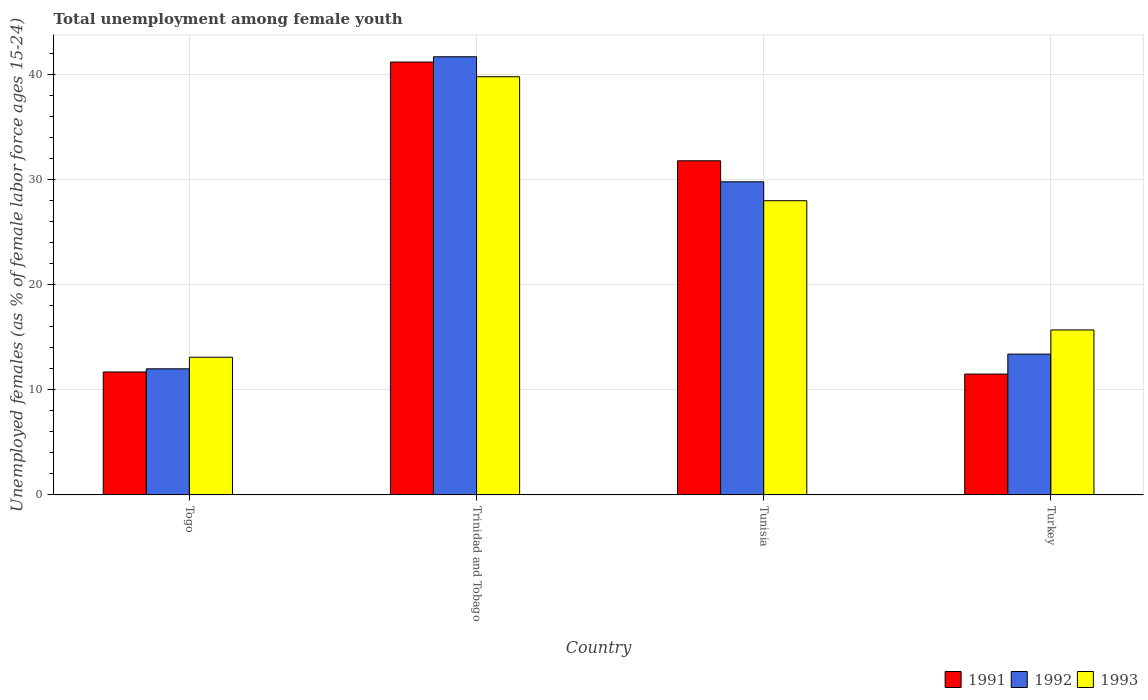How many different coloured bars are there?
Provide a succinct answer. 3. Are the number of bars per tick equal to the number of legend labels?
Offer a terse response. Yes. How many bars are there on the 2nd tick from the left?
Your answer should be compact. 3. What is the label of the 2nd group of bars from the left?
Your response must be concise. Trinidad and Tobago. What is the percentage of unemployed females in in 1992 in Trinidad and Tobago?
Offer a very short reply. 41.7. Across all countries, what is the maximum percentage of unemployed females in in 1992?
Ensure brevity in your answer.  41.7. Across all countries, what is the minimum percentage of unemployed females in in 1993?
Your answer should be very brief. 13.1. In which country was the percentage of unemployed females in in 1992 maximum?
Provide a succinct answer. Trinidad and Tobago. In which country was the percentage of unemployed females in in 1992 minimum?
Your answer should be very brief. Togo. What is the total percentage of unemployed females in in 1993 in the graph?
Your answer should be compact. 96.6. What is the difference between the percentage of unemployed females in in 1993 in Togo and that in Trinidad and Tobago?
Your response must be concise. -26.7. What is the difference between the percentage of unemployed females in in 1991 in Tunisia and the percentage of unemployed females in in 1992 in Trinidad and Tobago?
Provide a short and direct response. -9.9. What is the average percentage of unemployed females in in 1992 per country?
Your answer should be very brief. 24.22. What is the ratio of the percentage of unemployed females in in 1992 in Tunisia to that in Turkey?
Provide a short and direct response. 2.22. Is the percentage of unemployed females in in 1992 in Tunisia less than that in Turkey?
Offer a very short reply. No. Is the difference between the percentage of unemployed females in in 1991 in Trinidad and Tobago and Turkey greater than the difference between the percentage of unemployed females in in 1992 in Trinidad and Tobago and Turkey?
Your answer should be compact. Yes. What is the difference between the highest and the second highest percentage of unemployed females in in 1991?
Offer a very short reply. 29.5. What is the difference between the highest and the lowest percentage of unemployed females in in 1992?
Ensure brevity in your answer.  29.7. In how many countries, is the percentage of unemployed females in in 1991 greater than the average percentage of unemployed females in in 1991 taken over all countries?
Make the answer very short. 2. What does the 3rd bar from the right in Tunisia represents?
Provide a succinct answer. 1991. Is it the case that in every country, the sum of the percentage of unemployed females in in 1993 and percentage of unemployed females in in 1992 is greater than the percentage of unemployed females in in 1991?
Ensure brevity in your answer.  Yes. How many bars are there?
Your answer should be very brief. 12. Are all the bars in the graph horizontal?
Make the answer very short. No. How many countries are there in the graph?
Offer a very short reply. 4. What is the difference between two consecutive major ticks on the Y-axis?
Provide a succinct answer. 10. Are the values on the major ticks of Y-axis written in scientific E-notation?
Provide a short and direct response. No. Does the graph contain grids?
Your answer should be very brief. Yes. Where does the legend appear in the graph?
Keep it short and to the point. Bottom right. What is the title of the graph?
Your response must be concise. Total unemployment among female youth. Does "1991" appear as one of the legend labels in the graph?
Offer a terse response. Yes. What is the label or title of the X-axis?
Your answer should be compact. Country. What is the label or title of the Y-axis?
Ensure brevity in your answer.  Unemployed females (as % of female labor force ages 15-24). What is the Unemployed females (as % of female labor force ages 15-24) of 1991 in Togo?
Make the answer very short. 11.7. What is the Unemployed females (as % of female labor force ages 15-24) in 1993 in Togo?
Your answer should be compact. 13.1. What is the Unemployed females (as % of female labor force ages 15-24) in 1991 in Trinidad and Tobago?
Provide a short and direct response. 41.2. What is the Unemployed females (as % of female labor force ages 15-24) of 1992 in Trinidad and Tobago?
Your answer should be very brief. 41.7. What is the Unemployed females (as % of female labor force ages 15-24) of 1993 in Trinidad and Tobago?
Give a very brief answer. 39.8. What is the Unemployed females (as % of female labor force ages 15-24) in 1991 in Tunisia?
Provide a succinct answer. 31.8. What is the Unemployed females (as % of female labor force ages 15-24) in 1992 in Tunisia?
Ensure brevity in your answer.  29.8. What is the Unemployed females (as % of female labor force ages 15-24) in 1992 in Turkey?
Offer a terse response. 13.4. What is the Unemployed females (as % of female labor force ages 15-24) in 1993 in Turkey?
Provide a short and direct response. 15.7. Across all countries, what is the maximum Unemployed females (as % of female labor force ages 15-24) in 1991?
Your answer should be compact. 41.2. Across all countries, what is the maximum Unemployed females (as % of female labor force ages 15-24) in 1992?
Make the answer very short. 41.7. Across all countries, what is the maximum Unemployed females (as % of female labor force ages 15-24) in 1993?
Your answer should be very brief. 39.8. Across all countries, what is the minimum Unemployed females (as % of female labor force ages 15-24) in 1992?
Offer a very short reply. 12. Across all countries, what is the minimum Unemployed females (as % of female labor force ages 15-24) of 1993?
Provide a short and direct response. 13.1. What is the total Unemployed females (as % of female labor force ages 15-24) in 1991 in the graph?
Give a very brief answer. 96.2. What is the total Unemployed females (as % of female labor force ages 15-24) in 1992 in the graph?
Offer a very short reply. 96.9. What is the total Unemployed females (as % of female labor force ages 15-24) of 1993 in the graph?
Offer a terse response. 96.6. What is the difference between the Unemployed females (as % of female labor force ages 15-24) in 1991 in Togo and that in Trinidad and Tobago?
Ensure brevity in your answer.  -29.5. What is the difference between the Unemployed females (as % of female labor force ages 15-24) in 1992 in Togo and that in Trinidad and Tobago?
Your answer should be compact. -29.7. What is the difference between the Unemployed females (as % of female labor force ages 15-24) in 1993 in Togo and that in Trinidad and Tobago?
Offer a terse response. -26.7. What is the difference between the Unemployed females (as % of female labor force ages 15-24) in 1991 in Togo and that in Tunisia?
Keep it short and to the point. -20.1. What is the difference between the Unemployed females (as % of female labor force ages 15-24) in 1992 in Togo and that in Tunisia?
Keep it short and to the point. -17.8. What is the difference between the Unemployed females (as % of female labor force ages 15-24) of 1993 in Togo and that in Tunisia?
Provide a succinct answer. -14.9. What is the difference between the Unemployed females (as % of female labor force ages 15-24) of 1992 in Togo and that in Turkey?
Offer a terse response. -1.4. What is the difference between the Unemployed females (as % of female labor force ages 15-24) of 1993 in Trinidad and Tobago and that in Tunisia?
Offer a very short reply. 11.8. What is the difference between the Unemployed females (as % of female labor force ages 15-24) in 1991 in Trinidad and Tobago and that in Turkey?
Give a very brief answer. 29.7. What is the difference between the Unemployed females (as % of female labor force ages 15-24) of 1992 in Trinidad and Tobago and that in Turkey?
Your response must be concise. 28.3. What is the difference between the Unemployed females (as % of female labor force ages 15-24) in 1993 in Trinidad and Tobago and that in Turkey?
Give a very brief answer. 24.1. What is the difference between the Unemployed females (as % of female labor force ages 15-24) of 1991 in Tunisia and that in Turkey?
Your answer should be very brief. 20.3. What is the difference between the Unemployed females (as % of female labor force ages 15-24) of 1993 in Tunisia and that in Turkey?
Provide a short and direct response. 12.3. What is the difference between the Unemployed females (as % of female labor force ages 15-24) of 1991 in Togo and the Unemployed females (as % of female labor force ages 15-24) of 1993 in Trinidad and Tobago?
Give a very brief answer. -28.1. What is the difference between the Unemployed females (as % of female labor force ages 15-24) of 1992 in Togo and the Unemployed females (as % of female labor force ages 15-24) of 1993 in Trinidad and Tobago?
Your answer should be compact. -27.8. What is the difference between the Unemployed females (as % of female labor force ages 15-24) of 1991 in Togo and the Unemployed females (as % of female labor force ages 15-24) of 1992 in Tunisia?
Provide a short and direct response. -18.1. What is the difference between the Unemployed females (as % of female labor force ages 15-24) in 1991 in Togo and the Unemployed females (as % of female labor force ages 15-24) in 1993 in Tunisia?
Ensure brevity in your answer.  -16.3. What is the difference between the Unemployed females (as % of female labor force ages 15-24) of 1992 in Togo and the Unemployed females (as % of female labor force ages 15-24) of 1993 in Tunisia?
Offer a very short reply. -16. What is the difference between the Unemployed females (as % of female labor force ages 15-24) of 1992 in Togo and the Unemployed females (as % of female labor force ages 15-24) of 1993 in Turkey?
Give a very brief answer. -3.7. What is the difference between the Unemployed females (as % of female labor force ages 15-24) of 1991 in Trinidad and Tobago and the Unemployed females (as % of female labor force ages 15-24) of 1992 in Tunisia?
Provide a short and direct response. 11.4. What is the difference between the Unemployed females (as % of female labor force ages 15-24) in 1991 in Trinidad and Tobago and the Unemployed females (as % of female labor force ages 15-24) in 1993 in Tunisia?
Offer a very short reply. 13.2. What is the difference between the Unemployed females (as % of female labor force ages 15-24) of 1992 in Trinidad and Tobago and the Unemployed females (as % of female labor force ages 15-24) of 1993 in Tunisia?
Keep it short and to the point. 13.7. What is the difference between the Unemployed females (as % of female labor force ages 15-24) of 1991 in Trinidad and Tobago and the Unemployed females (as % of female labor force ages 15-24) of 1992 in Turkey?
Keep it short and to the point. 27.8. What is the difference between the Unemployed females (as % of female labor force ages 15-24) in 1992 in Trinidad and Tobago and the Unemployed females (as % of female labor force ages 15-24) in 1993 in Turkey?
Provide a short and direct response. 26. What is the difference between the Unemployed females (as % of female labor force ages 15-24) in 1992 in Tunisia and the Unemployed females (as % of female labor force ages 15-24) in 1993 in Turkey?
Keep it short and to the point. 14.1. What is the average Unemployed females (as % of female labor force ages 15-24) of 1991 per country?
Give a very brief answer. 24.05. What is the average Unemployed females (as % of female labor force ages 15-24) in 1992 per country?
Make the answer very short. 24.23. What is the average Unemployed females (as % of female labor force ages 15-24) of 1993 per country?
Provide a short and direct response. 24.15. What is the difference between the Unemployed females (as % of female labor force ages 15-24) of 1991 and Unemployed females (as % of female labor force ages 15-24) of 1992 in Trinidad and Tobago?
Offer a terse response. -0.5. What is the difference between the Unemployed females (as % of female labor force ages 15-24) in 1992 and Unemployed females (as % of female labor force ages 15-24) in 1993 in Trinidad and Tobago?
Offer a very short reply. 1.9. What is the difference between the Unemployed females (as % of female labor force ages 15-24) of 1991 and Unemployed females (as % of female labor force ages 15-24) of 1993 in Tunisia?
Provide a succinct answer. 3.8. What is the difference between the Unemployed females (as % of female labor force ages 15-24) of 1992 and Unemployed females (as % of female labor force ages 15-24) of 1993 in Turkey?
Provide a short and direct response. -2.3. What is the ratio of the Unemployed females (as % of female labor force ages 15-24) of 1991 in Togo to that in Trinidad and Tobago?
Keep it short and to the point. 0.28. What is the ratio of the Unemployed females (as % of female labor force ages 15-24) of 1992 in Togo to that in Trinidad and Tobago?
Give a very brief answer. 0.29. What is the ratio of the Unemployed females (as % of female labor force ages 15-24) in 1993 in Togo to that in Trinidad and Tobago?
Your answer should be very brief. 0.33. What is the ratio of the Unemployed females (as % of female labor force ages 15-24) in 1991 in Togo to that in Tunisia?
Provide a short and direct response. 0.37. What is the ratio of the Unemployed females (as % of female labor force ages 15-24) in 1992 in Togo to that in Tunisia?
Offer a very short reply. 0.4. What is the ratio of the Unemployed females (as % of female labor force ages 15-24) in 1993 in Togo to that in Tunisia?
Give a very brief answer. 0.47. What is the ratio of the Unemployed females (as % of female labor force ages 15-24) of 1991 in Togo to that in Turkey?
Give a very brief answer. 1.02. What is the ratio of the Unemployed females (as % of female labor force ages 15-24) of 1992 in Togo to that in Turkey?
Provide a succinct answer. 0.9. What is the ratio of the Unemployed females (as % of female labor force ages 15-24) in 1993 in Togo to that in Turkey?
Keep it short and to the point. 0.83. What is the ratio of the Unemployed females (as % of female labor force ages 15-24) of 1991 in Trinidad and Tobago to that in Tunisia?
Make the answer very short. 1.3. What is the ratio of the Unemployed females (as % of female labor force ages 15-24) in 1992 in Trinidad and Tobago to that in Tunisia?
Give a very brief answer. 1.4. What is the ratio of the Unemployed females (as % of female labor force ages 15-24) of 1993 in Trinidad and Tobago to that in Tunisia?
Ensure brevity in your answer.  1.42. What is the ratio of the Unemployed females (as % of female labor force ages 15-24) of 1991 in Trinidad and Tobago to that in Turkey?
Your answer should be very brief. 3.58. What is the ratio of the Unemployed females (as % of female labor force ages 15-24) of 1992 in Trinidad and Tobago to that in Turkey?
Your response must be concise. 3.11. What is the ratio of the Unemployed females (as % of female labor force ages 15-24) of 1993 in Trinidad and Tobago to that in Turkey?
Offer a terse response. 2.54. What is the ratio of the Unemployed females (as % of female labor force ages 15-24) of 1991 in Tunisia to that in Turkey?
Your answer should be very brief. 2.77. What is the ratio of the Unemployed females (as % of female labor force ages 15-24) of 1992 in Tunisia to that in Turkey?
Make the answer very short. 2.22. What is the ratio of the Unemployed females (as % of female labor force ages 15-24) in 1993 in Tunisia to that in Turkey?
Keep it short and to the point. 1.78. What is the difference between the highest and the lowest Unemployed females (as % of female labor force ages 15-24) of 1991?
Offer a terse response. 29.7. What is the difference between the highest and the lowest Unemployed females (as % of female labor force ages 15-24) in 1992?
Offer a terse response. 29.7. What is the difference between the highest and the lowest Unemployed females (as % of female labor force ages 15-24) in 1993?
Offer a terse response. 26.7. 